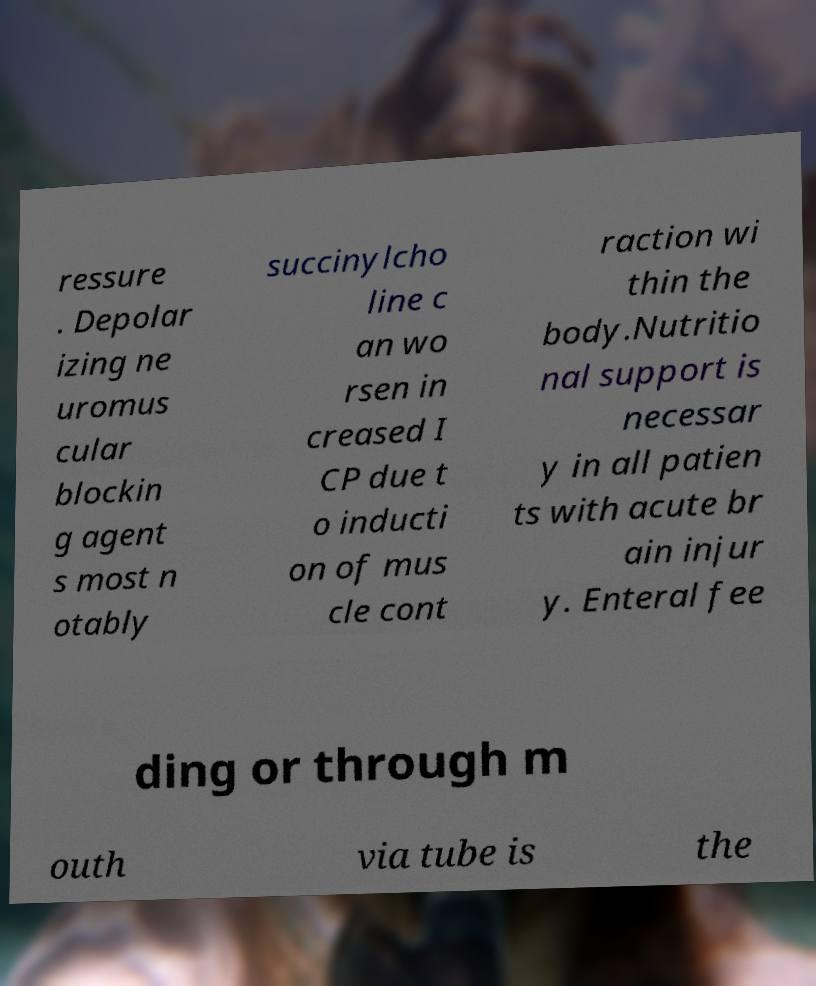For documentation purposes, I need the text within this image transcribed. Could you provide that? ressure . Depolar izing ne uromus cular blockin g agent s most n otably succinylcho line c an wo rsen in creased I CP due t o inducti on of mus cle cont raction wi thin the body.Nutritio nal support is necessar y in all patien ts with acute br ain injur y. Enteral fee ding or through m outh via tube is the 